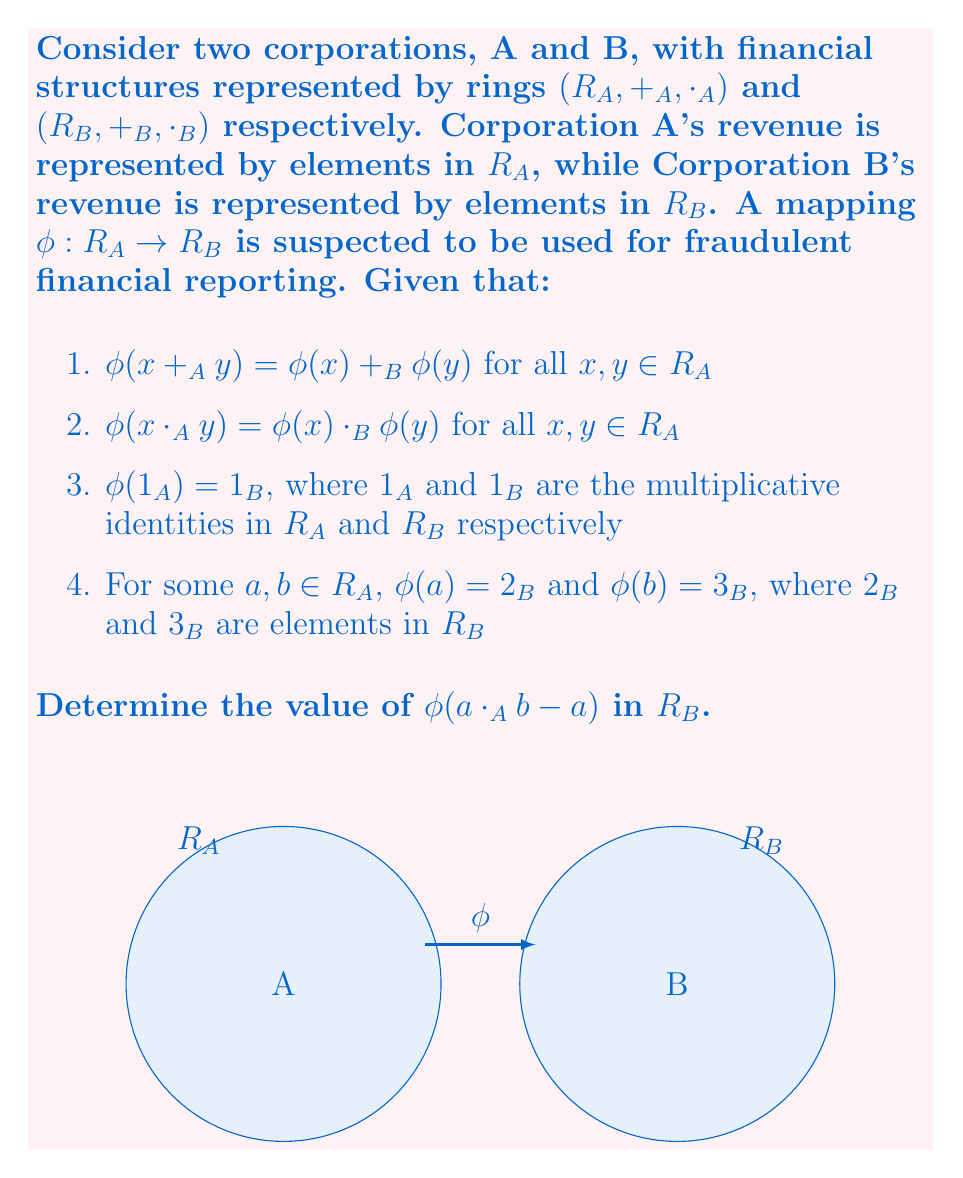What is the answer to this math problem? Let's approach this step-by-step:

1) First, we need to recognize that $\phi$ is a ring homomorphism from $R_A$ to $R_B$, as it satisfies the three conditions of a ring homomorphism (preserves addition, multiplication, and maps the multiplicative identity).

2) We are asked to find $\phi(a \cdot_A b - a)$. Let's break this down using the properties of ring homomorphisms:

   $\phi(a \cdot_A b - a) = \phi(a \cdot_A b) -_B \phi(a)$

3) Now, using the multiplication preservation property of $\phi$:

   $\phi(a \cdot_A b) -_B \phi(a) = \phi(a) \cdot_B \phi(b) -_B \phi(a)$

4) We're given that $\phi(a) = 2_B$ and $\phi(b) = 3_B$, so we can substitute these:

   $2_B \cdot_B 3_B -_B 2_B$

5) In the ring $R_B$, this is equivalent to:

   $6_B -_B 2_B = 4_B$

Therefore, $\phi(a \cdot_A b - a) = 4_B$.

This result demonstrates how the homomorphism $\phi$ maps the financial operations in Corporation A to corresponding operations in Corporation B, potentially masking fraudulent activities.
Answer: $4_B$ 